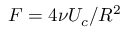<formula> <loc_0><loc_0><loc_500><loc_500>F = 4 \nu U _ { c } / R ^ { 2 }</formula> 